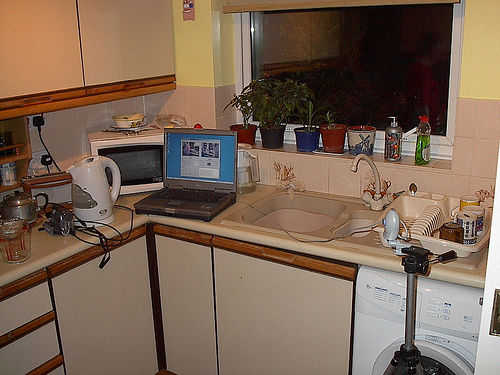<image>What color are the flowers on the counter? I don't know the color of the flowers on the counter. It can be green, white, brown or red, or there might be no flowers at all. What color glass is in the dish drainer? I am not sure about the color of the glass in the dish drainer. It can be white or brown. What color are the flowers on the counter? It is ambiguous what color the flowers on the counter are. They can be seen green, white, brown or red. What color glass is in the dish drainer? I am not sure what color glass is in the dish drainer. It can be either white, brown or none shown. 